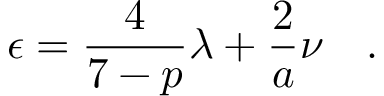Convert formula to latex. <formula><loc_0><loc_0><loc_500><loc_500>\epsilon = \frac { 4 } { 7 - p } { \lambda } + \frac { 2 } { a } \nu \quad .</formula> 